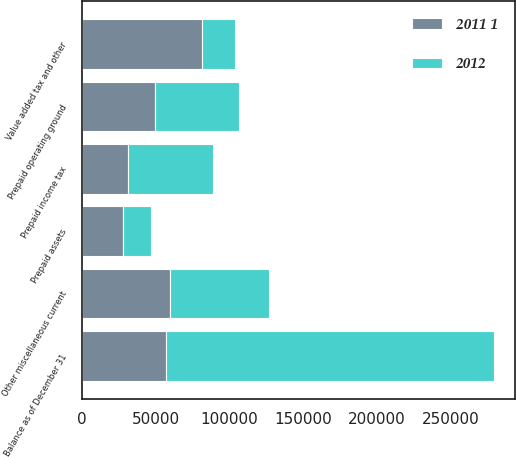<chart> <loc_0><loc_0><loc_500><loc_500><stacked_bar_chart><ecel><fcel>Prepaid income tax<fcel>Prepaid operating ground<fcel>Value added tax and other<fcel>Prepaid assets<fcel>Other miscellaneous current<fcel>Balance as of December 31<nl><fcel>2012<fcel>57665<fcel>56916<fcel>22443<fcel>19037<fcel>66790<fcel>222851<nl><fcel>2011 1<fcel>31384<fcel>49585<fcel>81276<fcel>28031<fcel>59997<fcel>56916<nl></chart> 